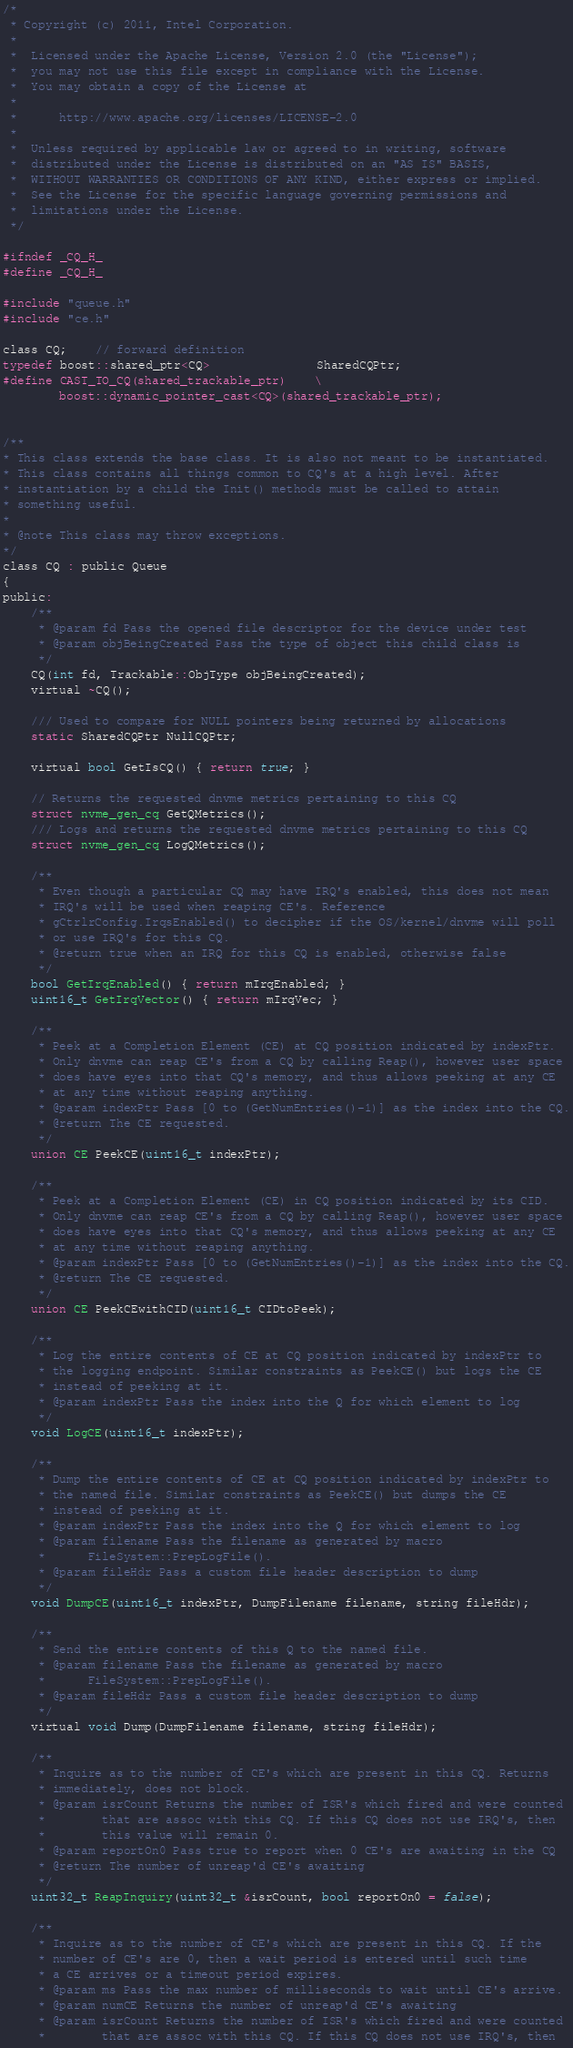<code> <loc_0><loc_0><loc_500><loc_500><_C_>/*
 * Copyright (c) 2011, Intel Corporation.
 *
 *  Licensed under the Apache License, Version 2.0 (the "License");
 *  you may not use this file except in compliance with the License.
 *  You may obtain a copy of the License at
 *
 *      http://www.apache.org/licenses/LICENSE-2.0
 *
 *  Unless required by applicable law or agreed to in writing, software
 *  distributed under the License is distributed on an "AS IS" BASIS,
 *  WITHOUT WARRANTIES OR CONDITIONS OF ANY KIND, either express or implied.
 *  See the License for the specific language governing permissions and
 *  limitations under the License.
 */

#ifndef _CQ_H_
#define _CQ_H_

#include "queue.h"
#include "ce.h"

class CQ;    // forward definition
typedef boost::shared_ptr<CQ>               SharedCQPtr;
#define CAST_TO_CQ(shared_trackable_ptr)    \
        boost::dynamic_pointer_cast<CQ>(shared_trackable_ptr);


/**
* This class extends the base class. It is also not meant to be instantiated.
* This class contains all things common to CQ's at a high level. After
* instantiation by a child the Init() methods must be called to attain
* something useful.
*
* @note This class may throw exceptions.
*/
class CQ : public Queue
{
public:
    /**
     * @param fd Pass the opened file descriptor for the device under test
     * @param objBeingCreated Pass the type of object this child class is
     */
    CQ(int fd, Trackable::ObjType objBeingCreated);
    virtual ~CQ();

    /// Used to compare for NULL pointers being returned by allocations
    static SharedCQPtr NullCQPtr;

    virtual bool GetIsCQ() { return true; }

    // Returns the requested dnvme metrics pertaining to this CQ
    struct nvme_gen_cq GetQMetrics();
    /// Logs and returns the requested dnvme metrics pertaining to this CQ
    struct nvme_gen_cq LogQMetrics();

    /**
     * Even though a particular CQ may have IRQ's enabled, this does not mean
     * IRQ's will be used when reaping CE's. Reference
     * gCtrlrConfig.IrqsEnabled() to decipher if the OS/kernel/dnvme will poll
     * or use IRQ's for this CQ.
     * @return true when an IRQ for this CQ is enabled, otherwise false
     */
    bool GetIrqEnabled() { return mIrqEnabled; }
    uint16_t GetIrqVector() { return mIrqVec; }

    /**
     * Peek at a Completion Element (CE) at CQ position indicated by indexPtr.
     * Only dnvme can reap CE's from a CQ by calling Reap(), however user space
     * does have eyes into that CQ's memory, and thus allows peeking at any CE
     * at any time without reaping anything.
     * @param indexPtr Pass [0 to (GetNumEntries()-1)] as the index into the CQ.
     * @return The CE requested.
     */
    union CE PeekCE(uint16_t indexPtr);
	
    /**
     * Peek at a Completion Element (CE) in CQ position indicated by its CID.
     * Only dnvme can reap CE's from a CQ by calling Reap(), however user space
     * does have eyes into that CQ's memory, and thus allows peeking at any CE
     * at any time without reaping anything.
     * @param indexPtr Pass [0 to (GetNumEntries()-1)] as the index into the CQ.
     * @return The CE requested.
     */	
    union CE PeekCEwithCID(uint16_t CIDtoPeek);

    /**
     * Log the entire contents of CE at CQ position indicated by indexPtr to
     * the logging endpoint. Similar constraints as PeekCE() but logs the CE
     * instead of peeking at it.
     * @param indexPtr Pass the index into the Q for which element to log
     */
    void LogCE(uint16_t indexPtr);

    /**
     * Dump the entire contents of CE at CQ position indicated by indexPtr to
     * the named file. Similar constraints as PeekCE() but dumps the CE
     * instead of peeking at it.
     * @param indexPtr Pass the index into the Q for which element to log
     * @param filename Pass the filename as generated by macro
     *      FileSystem::PrepLogFile().
     * @param fileHdr Pass a custom file header description to dump
     */
    void DumpCE(uint16_t indexPtr, DumpFilename filename, string fileHdr);

    /**
     * Send the entire contents of this Q to the named file.
     * @param filename Pass the filename as generated by macro
     *      FileSystem::PrepLogFile().
     * @param fileHdr Pass a custom file header description to dump
     */
    virtual void Dump(DumpFilename filename, string fileHdr);

    /**
     * Inquire as to the number of CE's which are present in this CQ. Returns
     * immediately, does not block.
     * @param isrCount Returns the number of ISR's which fired and were counted
     *        that are assoc with this CQ. If this CQ does not use IRQ's, then
     *        this value will remain 0.
     * @param reportOn0 Pass true to report when 0 CE's are awaiting in the CQ
     * @return The number of unreap'd CE's awaiting
     */
    uint32_t ReapInquiry(uint32_t &isrCount, bool reportOn0 = false);

    /**
     * Inquire as to the number of CE's which are present in this CQ. If the
     * number of CE's are 0, then a wait period is entered until such time
     * a CE arrives or a timeout period expires.
     * @param ms Pass the max number of milliseconds to wait until CE's arrive.
     * @param numCE Returns the number of unreap'd CE's awaiting
     * @param isrCount Returns the number of ISR's which fired and were counted
     *        that are assoc with this CQ. If this CQ does not use IRQ's, then</code> 